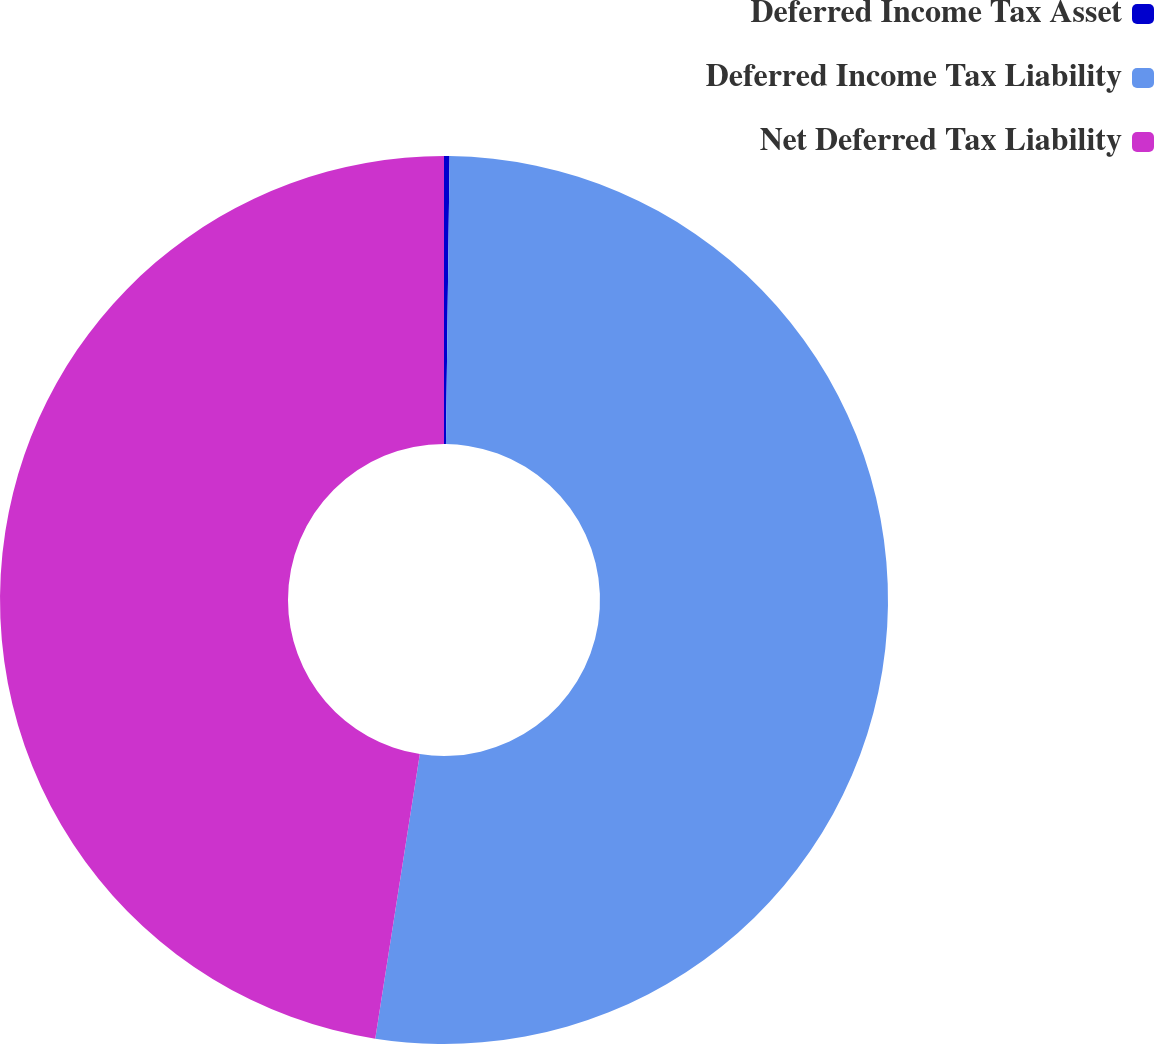Convert chart. <chart><loc_0><loc_0><loc_500><loc_500><pie_chart><fcel>Deferred Income Tax Asset<fcel>Deferred Income Tax Liability<fcel>Net Deferred Tax Liability<nl><fcel>0.2%<fcel>52.27%<fcel>47.52%<nl></chart> 